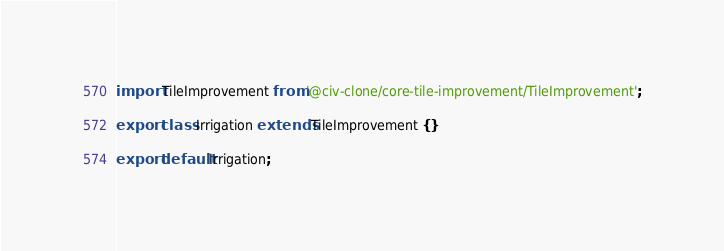Convert code to text. <code><loc_0><loc_0><loc_500><loc_500><_TypeScript_>import TileImprovement from '@civ-clone/core-tile-improvement/TileImprovement';

export class Irrigation extends TileImprovement {}

export default Irrigation;
</code> 